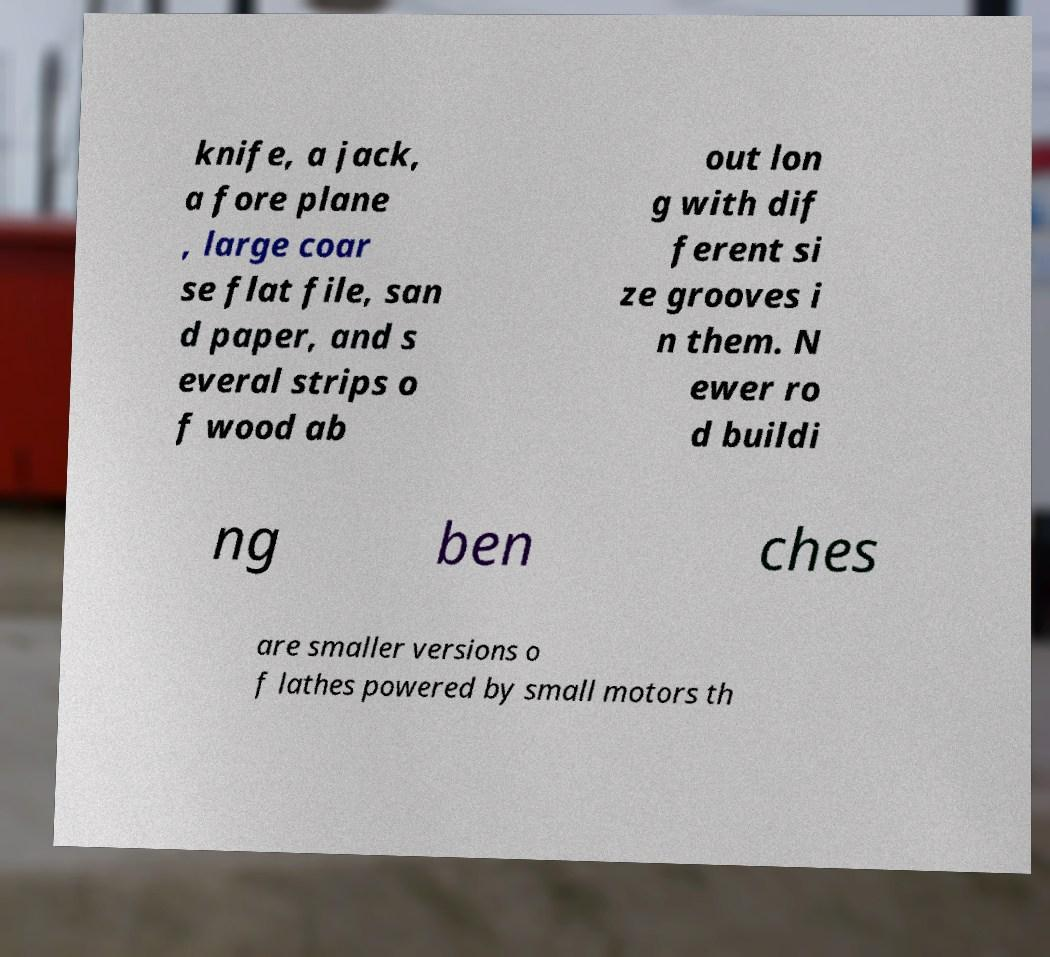Please read and relay the text visible in this image. What does it say? knife, a jack, a fore plane , large coar se flat file, san d paper, and s everal strips o f wood ab out lon g with dif ferent si ze grooves i n them. N ewer ro d buildi ng ben ches are smaller versions o f lathes powered by small motors th 